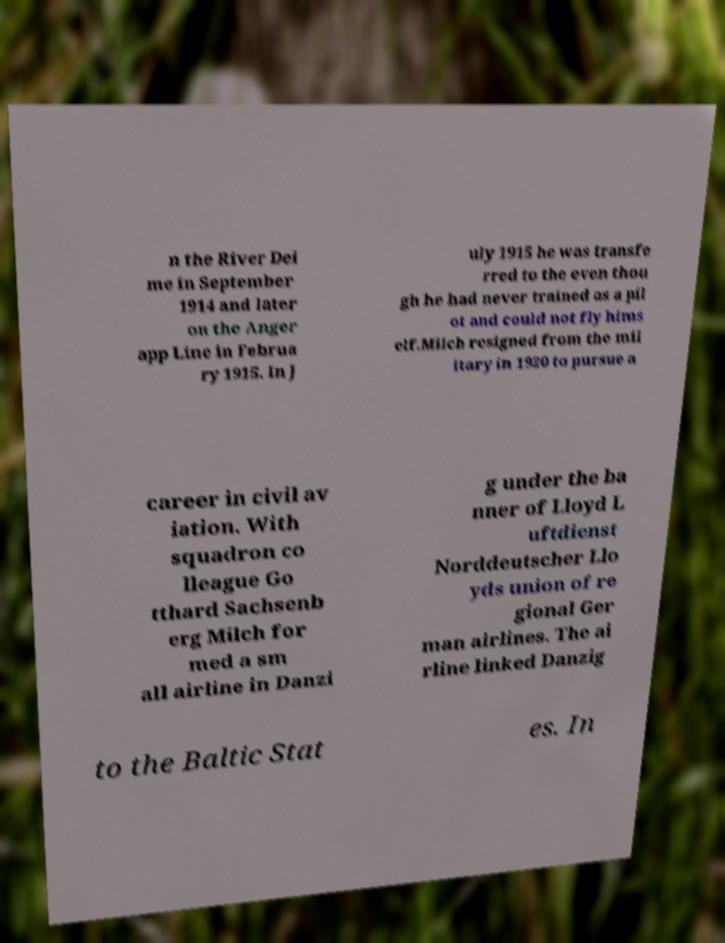For documentation purposes, I need the text within this image transcribed. Could you provide that? n the River Dei me in September 1914 and later on the Anger app Line in Februa ry 1915. In J uly 1915 he was transfe rred to the even thou gh he had never trained as a pil ot and could not fly hims elf.Milch resigned from the mil itary in 1920 to pursue a career in civil av iation. With squadron co lleague Go tthard Sachsenb erg Milch for med a sm all airline in Danzi g under the ba nner of Lloyd L uftdienst Norddeutscher Llo yds union of re gional Ger man airlines. The ai rline linked Danzig to the Baltic Stat es. In 